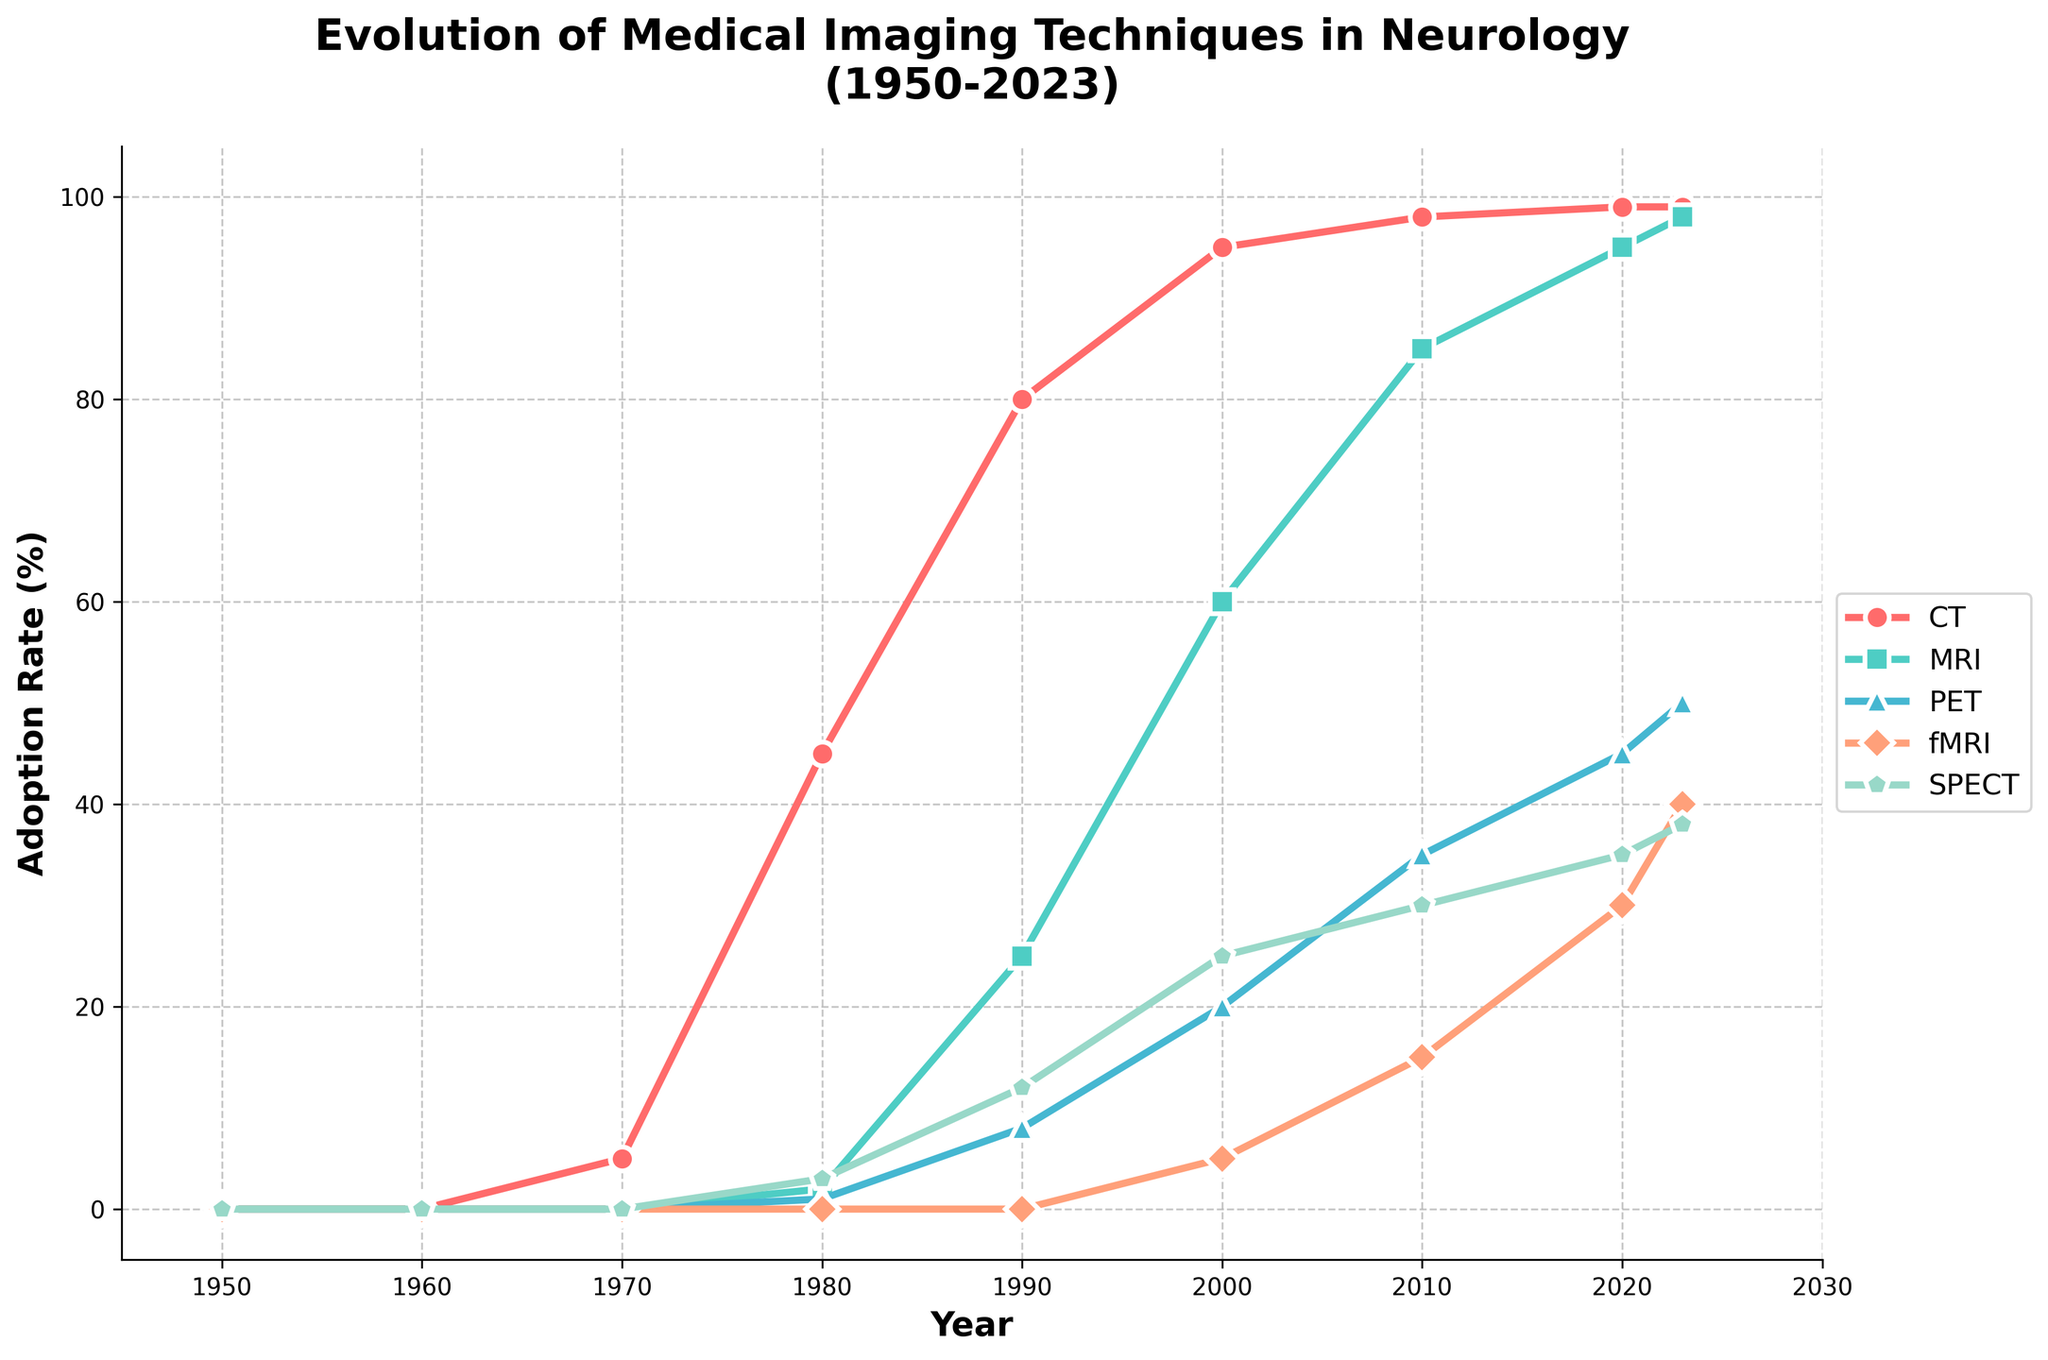How did the adoption rate of CT and MRI compare in 1980? In 1980, the adoption rate of CT was 45%, while the adoption rate of MRI was 2%. Comparison of the two rates shows that CT had a significantly higher adoption rate than MRI by 43 percentage points.
Answer: CT was higher by 43% By how much did the adoption rate of PET increase from 1990 to 2020? In 1990, the adoption rate of PET was 8%, and in 2020 it was 45%. The increase can be calculated by subtracting the earlier rate from the later rate: 45% - 8% = 37%.
Answer: 37% Which medical imaging technique had the highest adoption rate in 2023? Observing the adoption rates in 2023, CT had the highest adoption rate at 99%.
Answer: CT In which decade did fMRI first get adopted according to the plot? fMRI's adoption rate first appears in the plot in the year 2000 with a 5% adoption rate, indicating that the technique was first adopted in the 1990s.
Answer: 1990s What is the difference in the adoption rates of SPECT and PET in 2010? In 2010, the adoption rate of SPECT was 30%, while PET was at 35%. The difference is calculated by subtracting the adoption rate of SPECT from PET: 35% - 30% = 5%.
Answer: 5% Describe the visual trend in the adoption rate of MRI from 1970 to 2023. The adoption rate of MRI showed a gradual increase from 0% in 1970 to 98% in 2023. The growth was initially slow, becoming more rapid from 1980 to 2010, and slowing down again after 2010, indicating high adoption over time.
Answer: Gradually increasing How much did the adoption rate of CT change from 1950 to 2000? In 1950, the adoption rate of CT was 0%, and by 2000 it was 95%. We calculate the change by subtracting the initial value from the final value: 95% - 0% = 95%.
Answer: 95% Which two techniques had the closest adoption rates in 2020? In 2020, SPECT had an adoption rate of 35%, and PET had an adoption rate of 45%. The difference between their rates is 45% - 35% = 10%, making them the closest in adoption rates among the techniques.
Answer: SPECT and PET 